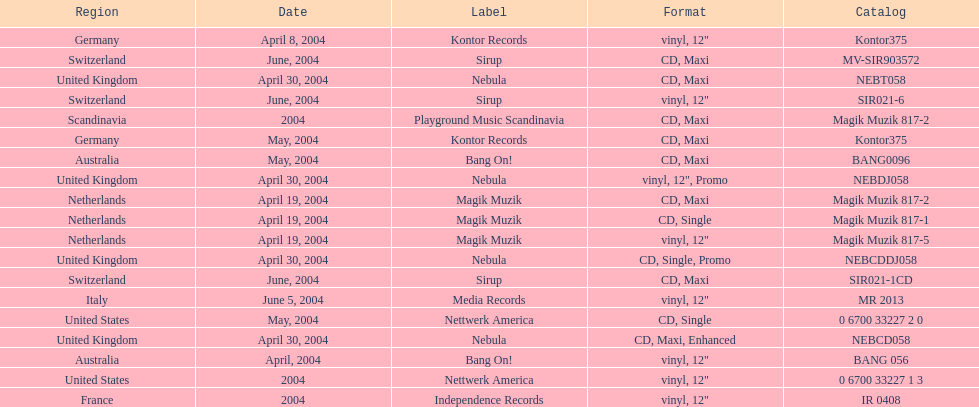What region was on the label sirup? Switzerland. 